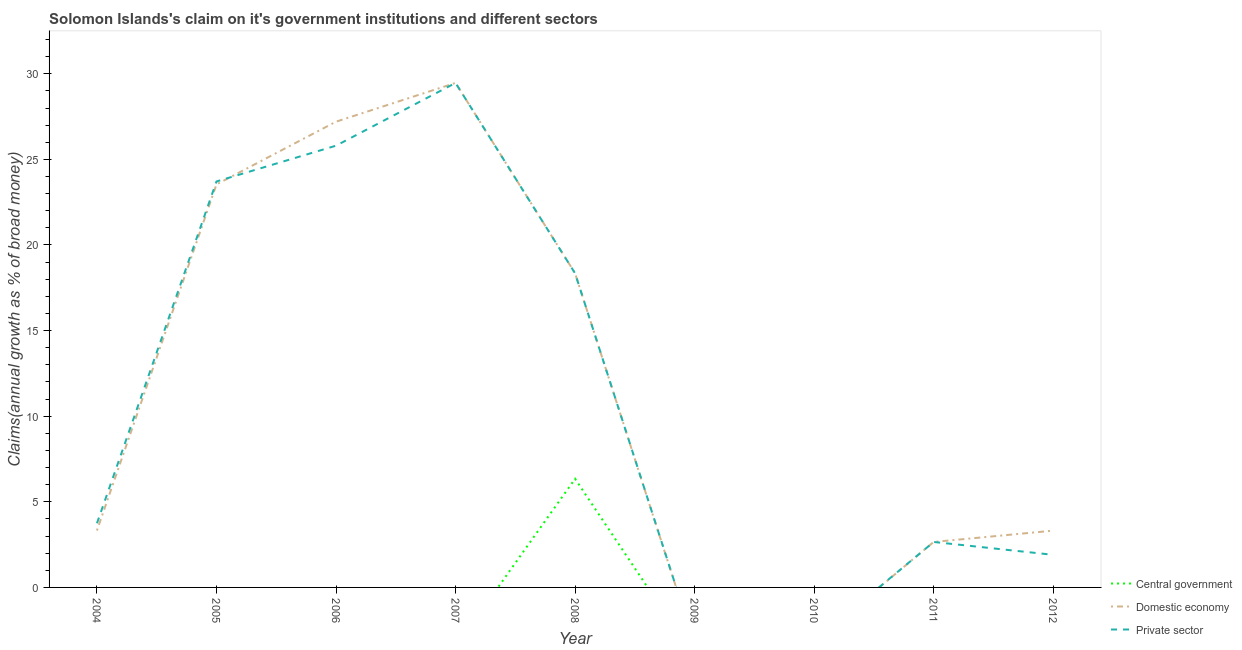Is the number of lines equal to the number of legend labels?
Offer a very short reply. No. What is the percentage of claim on the domestic economy in 2006?
Offer a terse response. 27.2. Across all years, what is the maximum percentage of claim on the domestic economy?
Ensure brevity in your answer.  29.47. In which year was the percentage of claim on the private sector maximum?
Ensure brevity in your answer.  2007. What is the total percentage of claim on the domestic economy in the graph?
Keep it short and to the point. 107.85. What is the difference between the percentage of claim on the private sector in 2006 and that in 2007?
Your answer should be very brief. -3.66. What is the average percentage of claim on the central government per year?
Offer a very short reply. 0.7. In the year 2007, what is the difference between the percentage of claim on the private sector and percentage of claim on the domestic economy?
Your answer should be very brief. -0. In how many years, is the percentage of claim on the private sector greater than 19 %?
Keep it short and to the point. 3. What is the ratio of the percentage of claim on the domestic economy in 2004 to that in 2012?
Provide a short and direct response. 1. Is the percentage of claim on the private sector in 2004 less than that in 2012?
Ensure brevity in your answer.  No. What is the difference between the highest and the second highest percentage of claim on the private sector?
Your answer should be very brief. 3.66. What is the difference between the highest and the lowest percentage of claim on the private sector?
Give a very brief answer. 29.47. In how many years, is the percentage of claim on the central government greater than the average percentage of claim on the central government taken over all years?
Give a very brief answer. 1. Is the sum of the percentage of claim on the private sector in 2007 and 2011 greater than the maximum percentage of claim on the domestic economy across all years?
Keep it short and to the point. Yes. Is it the case that in every year, the sum of the percentage of claim on the central government and percentage of claim on the domestic economy is greater than the percentage of claim on the private sector?
Offer a terse response. No. Does the graph contain any zero values?
Offer a very short reply. Yes. Does the graph contain grids?
Keep it short and to the point. No. How many legend labels are there?
Give a very brief answer. 3. How are the legend labels stacked?
Ensure brevity in your answer.  Vertical. What is the title of the graph?
Your answer should be very brief. Solomon Islands's claim on it's government institutions and different sectors. Does "Czech Republic" appear as one of the legend labels in the graph?
Keep it short and to the point. No. What is the label or title of the X-axis?
Ensure brevity in your answer.  Year. What is the label or title of the Y-axis?
Your answer should be compact. Claims(annual growth as % of broad money). What is the Claims(annual growth as % of broad money) in Central government in 2004?
Offer a terse response. 0. What is the Claims(annual growth as % of broad money) of Domestic economy in 2004?
Give a very brief answer. 3.32. What is the Claims(annual growth as % of broad money) of Private sector in 2004?
Your response must be concise. 3.75. What is the Claims(annual growth as % of broad money) of Central government in 2005?
Provide a succinct answer. 0. What is the Claims(annual growth as % of broad money) of Domestic economy in 2005?
Provide a succinct answer. 23.54. What is the Claims(annual growth as % of broad money) of Private sector in 2005?
Provide a short and direct response. 23.71. What is the Claims(annual growth as % of broad money) of Domestic economy in 2006?
Offer a terse response. 27.2. What is the Claims(annual growth as % of broad money) of Private sector in 2006?
Give a very brief answer. 25.8. What is the Claims(annual growth as % of broad money) in Domestic economy in 2007?
Ensure brevity in your answer.  29.47. What is the Claims(annual growth as % of broad money) in Private sector in 2007?
Provide a succinct answer. 29.47. What is the Claims(annual growth as % of broad money) of Central government in 2008?
Make the answer very short. 6.34. What is the Claims(annual growth as % of broad money) of Domestic economy in 2008?
Keep it short and to the point. 18.35. What is the Claims(annual growth as % of broad money) of Private sector in 2008?
Your answer should be very brief. 18.35. What is the Claims(annual growth as % of broad money) of Private sector in 2009?
Keep it short and to the point. 0. What is the Claims(annual growth as % of broad money) in Central government in 2011?
Keep it short and to the point. 0. What is the Claims(annual growth as % of broad money) in Domestic economy in 2011?
Give a very brief answer. 2.66. What is the Claims(annual growth as % of broad money) in Private sector in 2011?
Offer a very short reply. 2.66. What is the Claims(annual growth as % of broad money) of Central government in 2012?
Provide a short and direct response. 0. What is the Claims(annual growth as % of broad money) of Domestic economy in 2012?
Your answer should be very brief. 3.32. What is the Claims(annual growth as % of broad money) of Private sector in 2012?
Offer a very short reply. 1.9. Across all years, what is the maximum Claims(annual growth as % of broad money) of Central government?
Your answer should be compact. 6.34. Across all years, what is the maximum Claims(annual growth as % of broad money) in Domestic economy?
Ensure brevity in your answer.  29.47. Across all years, what is the maximum Claims(annual growth as % of broad money) of Private sector?
Provide a short and direct response. 29.47. Across all years, what is the minimum Claims(annual growth as % of broad money) of Domestic economy?
Give a very brief answer. 0. What is the total Claims(annual growth as % of broad money) of Central government in the graph?
Offer a very short reply. 6.34. What is the total Claims(annual growth as % of broad money) in Domestic economy in the graph?
Your answer should be compact. 107.85. What is the total Claims(annual growth as % of broad money) in Private sector in the graph?
Keep it short and to the point. 105.63. What is the difference between the Claims(annual growth as % of broad money) of Domestic economy in 2004 and that in 2005?
Provide a short and direct response. -20.21. What is the difference between the Claims(annual growth as % of broad money) in Private sector in 2004 and that in 2005?
Your response must be concise. -19.96. What is the difference between the Claims(annual growth as % of broad money) of Domestic economy in 2004 and that in 2006?
Give a very brief answer. -23.88. What is the difference between the Claims(annual growth as % of broad money) in Private sector in 2004 and that in 2006?
Make the answer very short. -22.05. What is the difference between the Claims(annual growth as % of broad money) in Domestic economy in 2004 and that in 2007?
Make the answer very short. -26.14. What is the difference between the Claims(annual growth as % of broad money) of Private sector in 2004 and that in 2007?
Your response must be concise. -25.72. What is the difference between the Claims(annual growth as % of broad money) of Domestic economy in 2004 and that in 2008?
Your answer should be very brief. -15.02. What is the difference between the Claims(annual growth as % of broad money) of Private sector in 2004 and that in 2008?
Provide a short and direct response. -14.6. What is the difference between the Claims(annual growth as % of broad money) of Domestic economy in 2004 and that in 2011?
Offer a very short reply. 0.67. What is the difference between the Claims(annual growth as % of broad money) of Private sector in 2004 and that in 2011?
Provide a short and direct response. 1.09. What is the difference between the Claims(annual growth as % of broad money) of Domestic economy in 2004 and that in 2012?
Make the answer very short. 0.01. What is the difference between the Claims(annual growth as % of broad money) in Private sector in 2004 and that in 2012?
Give a very brief answer. 1.84. What is the difference between the Claims(annual growth as % of broad money) in Domestic economy in 2005 and that in 2006?
Your answer should be very brief. -3.66. What is the difference between the Claims(annual growth as % of broad money) of Private sector in 2005 and that in 2006?
Your response must be concise. -2.09. What is the difference between the Claims(annual growth as % of broad money) of Domestic economy in 2005 and that in 2007?
Your answer should be compact. -5.93. What is the difference between the Claims(annual growth as % of broad money) of Private sector in 2005 and that in 2007?
Provide a short and direct response. -5.76. What is the difference between the Claims(annual growth as % of broad money) of Domestic economy in 2005 and that in 2008?
Provide a succinct answer. 5.19. What is the difference between the Claims(annual growth as % of broad money) in Private sector in 2005 and that in 2008?
Your response must be concise. 5.36. What is the difference between the Claims(annual growth as % of broad money) in Domestic economy in 2005 and that in 2011?
Offer a very short reply. 20.88. What is the difference between the Claims(annual growth as % of broad money) of Private sector in 2005 and that in 2011?
Give a very brief answer. 21.06. What is the difference between the Claims(annual growth as % of broad money) of Domestic economy in 2005 and that in 2012?
Offer a terse response. 20.22. What is the difference between the Claims(annual growth as % of broad money) in Private sector in 2005 and that in 2012?
Provide a short and direct response. 21.81. What is the difference between the Claims(annual growth as % of broad money) in Domestic economy in 2006 and that in 2007?
Make the answer very short. -2.26. What is the difference between the Claims(annual growth as % of broad money) of Private sector in 2006 and that in 2007?
Provide a short and direct response. -3.66. What is the difference between the Claims(annual growth as % of broad money) in Domestic economy in 2006 and that in 2008?
Give a very brief answer. 8.86. What is the difference between the Claims(annual growth as % of broad money) in Private sector in 2006 and that in 2008?
Provide a succinct answer. 7.45. What is the difference between the Claims(annual growth as % of broad money) of Domestic economy in 2006 and that in 2011?
Keep it short and to the point. 24.55. What is the difference between the Claims(annual growth as % of broad money) of Private sector in 2006 and that in 2011?
Your response must be concise. 23.15. What is the difference between the Claims(annual growth as % of broad money) of Domestic economy in 2006 and that in 2012?
Offer a very short reply. 23.89. What is the difference between the Claims(annual growth as % of broad money) of Private sector in 2006 and that in 2012?
Keep it short and to the point. 23.9. What is the difference between the Claims(annual growth as % of broad money) of Domestic economy in 2007 and that in 2008?
Make the answer very short. 11.12. What is the difference between the Claims(annual growth as % of broad money) in Private sector in 2007 and that in 2008?
Provide a short and direct response. 11.12. What is the difference between the Claims(annual growth as % of broad money) of Domestic economy in 2007 and that in 2011?
Provide a succinct answer. 26.81. What is the difference between the Claims(annual growth as % of broad money) in Private sector in 2007 and that in 2011?
Make the answer very short. 26.81. What is the difference between the Claims(annual growth as % of broad money) in Domestic economy in 2007 and that in 2012?
Your answer should be very brief. 26.15. What is the difference between the Claims(annual growth as % of broad money) in Private sector in 2007 and that in 2012?
Provide a succinct answer. 27.56. What is the difference between the Claims(annual growth as % of broad money) of Domestic economy in 2008 and that in 2011?
Make the answer very short. 15.69. What is the difference between the Claims(annual growth as % of broad money) in Private sector in 2008 and that in 2011?
Provide a succinct answer. 15.69. What is the difference between the Claims(annual growth as % of broad money) in Domestic economy in 2008 and that in 2012?
Give a very brief answer. 15.03. What is the difference between the Claims(annual growth as % of broad money) in Private sector in 2008 and that in 2012?
Give a very brief answer. 16.44. What is the difference between the Claims(annual growth as % of broad money) of Domestic economy in 2011 and that in 2012?
Your answer should be compact. -0.66. What is the difference between the Claims(annual growth as % of broad money) of Private sector in 2011 and that in 2012?
Your response must be concise. 0.75. What is the difference between the Claims(annual growth as % of broad money) in Domestic economy in 2004 and the Claims(annual growth as % of broad money) in Private sector in 2005?
Give a very brief answer. -20.39. What is the difference between the Claims(annual growth as % of broad money) of Domestic economy in 2004 and the Claims(annual growth as % of broad money) of Private sector in 2006?
Provide a short and direct response. -22.48. What is the difference between the Claims(annual growth as % of broad money) in Domestic economy in 2004 and the Claims(annual growth as % of broad money) in Private sector in 2007?
Make the answer very short. -26.14. What is the difference between the Claims(annual growth as % of broad money) of Domestic economy in 2004 and the Claims(annual growth as % of broad money) of Private sector in 2008?
Provide a succinct answer. -15.02. What is the difference between the Claims(annual growth as % of broad money) in Domestic economy in 2004 and the Claims(annual growth as % of broad money) in Private sector in 2011?
Your response must be concise. 0.67. What is the difference between the Claims(annual growth as % of broad money) in Domestic economy in 2004 and the Claims(annual growth as % of broad money) in Private sector in 2012?
Your answer should be very brief. 1.42. What is the difference between the Claims(annual growth as % of broad money) of Domestic economy in 2005 and the Claims(annual growth as % of broad money) of Private sector in 2006?
Your answer should be very brief. -2.26. What is the difference between the Claims(annual growth as % of broad money) of Domestic economy in 2005 and the Claims(annual growth as % of broad money) of Private sector in 2007?
Keep it short and to the point. -5.93. What is the difference between the Claims(annual growth as % of broad money) in Domestic economy in 2005 and the Claims(annual growth as % of broad money) in Private sector in 2008?
Give a very brief answer. 5.19. What is the difference between the Claims(annual growth as % of broad money) in Domestic economy in 2005 and the Claims(annual growth as % of broad money) in Private sector in 2011?
Offer a very short reply. 20.88. What is the difference between the Claims(annual growth as % of broad money) of Domestic economy in 2005 and the Claims(annual growth as % of broad money) of Private sector in 2012?
Make the answer very short. 21.64. What is the difference between the Claims(annual growth as % of broad money) in Domestic economy in 2006 and the Claims(annual growth as % of broad money) in Private sector in 2007?
Provide a short and direct response. -2.26. What is the difference between the Claims(annual growth as % of broad money) in Domestic economy in 2006 and the Claims(annual growth as % of broad money) in Private sector in 2008?
Your response must be concise. 8.86. What is the difference between the Claims(annual growth as % of broad money) in Domestic economy in 2006 and the Claims(annual growth as % of broad money) in Private sector in 2011?
Ensure brevity in your answer.  24.55. What is the difference between the Claims(annual growth as % of broad money) in Domestic economy in 2006 and the Claims(annual growth as % of broad money) in Private sector in 2012?
Your response must be concise. 25.3. What is the difference between the Claims(annual growth as % of broad money) of Domestic economy in 2007 and the Claims(annual growth as % of broad money) of Private sector in 2008?
Ensure brevity in your answer.  11.12. What is the difference between the Claims(annual growth as % of broad money) in Domestic economy in 2007 and the Claims(annual growth as % of broad money) in Private sector in 2011?
Keep it short and to the point. 26.81. What is the difference between the Claims(annual growth as % of broad money) in Domestic economy in 2007 and the Claims(annual growth as % of broad money) in Private sector in 2012?
Your response must be concise. 27.56. What is the difference between the Claims(annual growth as % of broad money) in Central government in 2008 and the Claims(annual growth as % of broad money) in Domestic economy in 2011?
Your response must be concise. 3.69. What is the difference between the Claims(annual growth as % of broad money) in Central government in 2008 and the Claims(annual growth as % of broad money) in Private sector in 2011?
Your answer should be very brief. 3.69. What is the difference between the Claims(annual growth as % of broad money) of Domestic economy in 2008 and the Claims(annual growth as % of broad money) of Private sector in 2011?
Ensure brevity in your answer.  15.69. What is the difference between the Claims(annual growth as % of broad money) in Central government in 2008 and the Claims(annual growth as % of broad money) in Domestic economy in 2012?
Your answer should be compact. 3.03. What is the difference between the Claims(annual growth as % of broad money) in Central government in 2008 and the Claims(annual growth as % of broad money) in Private sector in 2012?
Provide a short and direct response. 4.44. What is the difference between the Claims(annual growth as % of broad money) in Domestic economy in 2008 and the Claims(annual growth as % of broad money) in Private sector in 2012?
Offer a very short reply. 16.44. What is the difference between the Claims(annual growth as % of broad money) of Domestic economy in 2011 and the Claims(annual growth as % of broad money) of Private sector in 2012?
Your answer should be compact. 0.75. What is the average Claims(annual growth as % of broad money) in Central government per year?
Keep it short and to the point. 0.7. What is the average Claims(annual growth as % of broad money) of Domestic economy per year?
Keep it short and to the point. 11.98. What is the average Claims(annual growth as % of broad money) in Private sector per year?
Ensure brevity in your answer.  11.74. In the year 2004, what is the difference between the Claims(annual growth as % of broad money) of Domestic economy and Claims(annual growth as % of broad money) of Private sector?
Your answer should be compact. -0.42. In the year 2005, what is the difference between the Claims(annual growth as % of broad money) in Domestic economy and Claims(annual growth as % of broad money) in Private sector?
Provide a succinct answer. -0.17. In the year 2006, what is the difference between the Claims(annual growth as % of broad money) of Domestic economy and Claims(annual growth as % of broad money) of Private sector?
Provide a short and direct response. 1.4. In the year 2007, what is the difference between the Claims(annual growth as % of broad money) in Domestic economy and Claims(annual growth as % of broad money) in Private sector?
Your response must be concise. 0. In the year 2008, what is the difference between the Claims(annual growth as % of broad money) of Central government and Claims(annual growth as % of broad money) of Domestic economy?
Provide a succinct answer. -12. In the year 2008, what is the difference between the Claims(annual growth as % of broad money) of Central government and Claims(annual growth as % of broad money) of Private sector?
Your response must be concise. -12. In the year 2008, what is the difference between the Claims(annual growth as % of broad money) of Domestic economy and Claims(annual growth as % of broad money) of Private sector?
Offer a very short reply. 0. In the year 2011, what is the difference between the Claims(annual growth as % of broad money) of Domestic economy and Claims(annual growth as % of broad money) of Private sector?
Your response must be concise. 0. In the year 2012, what is the difference between the Claims(annual growth as % of broad money) of Domestic economy and Claims(annual growth as % of broad money) of Private sector?
Offer a terse response. 1.41. What is the ratio of the Claims(annual growth as % of broad money) in Domestic economy in 2004 to that in 2005?
Offer a very short reply. 0.14. What is the ratio of the Claims(annual growth as % of broad money) of Private sector in 2004 to that in 2005?
Your answer should be compact. 0.16. What is the ratio of the Claims(annual growth as % of broad money) of Domestic economy in 2004 to that in 2006?
Provide a succinct answer. 0.12. What is the ratio of the Claims(annual growth as % of broad money) of Private sector in 2004 to that in 2006?
Keep it short and to the point. 0.15. What is the ratio of the Claims(annual growth as % of broad money) in Domestic economy in 2004 to that in 2007?
Your answer should be compact. 0.11. What is the ratio of the Claims(annual growth as % of broad money) in Private sector in 2004 to that in 2007?
Your answer should be very brief. 0.13. What is the ratio of the Claims(annual growth as % of broad money) in Domestic economy in 2004 to that in 2008?
Your answer should be very brief. 0.18. What is the ratio of the Claims(annual growth as % of broad money) of Private sector in 2004 to that in 2008?
Give a very brief answer. 0.2. What is the ratio of the Claims(annual growth as % of broad money) of Domestic economy in 2004 to that in 2011?
Give a very brief answer. 1.25. What is the ratio of the Claims(annual growth as % of broad money) in Private sector in 2004 to that in 2011?
Give a very brief answer. 1.41. What is the ratio of the Claims(annual growth as % of broad money) of Domestic economy in 2004 to that in 2012?
Offer a very short reply. 1. What is the ratio of the Claims(annual growth as % of broad money) of Private sector in 2004 to that in 2012?
Provide a short and direct response. 1.97. What is the ratio of the Claims(annual growth as % of broad money) of Domestic economy in 2005 to that in 2006?
Your answer should be very brief. 0.87. What is the ratio of the Claims(annual growth as % of broad money) in Private sector in 2005 to that in 2006?
Keep it short and to the point. 0.92. What is the ratio of the Claims(annual growth as % of broad money) in Domestic economy in 2005 to that in 2007?
Your answer should be compact. 0.8. What is the ratio of the Claims(annual growth as % of broad money) in Private sector in 2005 to that in 2007?
Offer a terse response. 0.8. What is the ratio of the Claims(annual growth as % of broad money) of Domestic economy in 2005 to that in 2008?
Your response must be concise. 1.28. What is the ratio of the Claims(annual growth as % of broad money) in Private sector in 2005 to that in 2008?
Your answer should be compact. 1.29. What is the ratio of the Claims(annual growth as % of broad money) in Domestic economy in 2005 to that in 2011?
Your response must be concise. 8.86. What is the ratio of the Claims(annual growth as % of broad money) in Private sector in 2005 to that in 2011?
Your answer should be very brief. 8.93. What is the ratio of the Claims(annual growth as % of broad money) of Domestic economy in 2005 to that in 2012?
Ensure brevity in your answer.  7.1. What is the ratio of the Claims(annual growth as % of broad money) in Private sector in 2005 to that in 2012?
Provide a succinct answer. 12.46. What is the ratio of the Claims(annual growth as % of broad money) in Domestic economy in 2006 to that in 2007?
Provide a succinct answer. 0.92. What is the ratio of the Claims(annual growth as % of broad money) in Private sector in 2006 to that in 2007?
Give a very brief answer. 0.88. What is the ratio of the Claims(annual growth as % of broad money) of Domestic economy in 2006 to that in 2008?
Your answer should be compact. 1.48. What is the ratio of the Claims(annual growth as % of broad money) of Private sector in 2006 to that in 2008?
Your answer should be compact. 1.41. What is the ratio of the Claims(annual growth as % of broad money) of Domestic economy in 2006 to that in 2011?
Offer a terse response. 10.24. What is the ratio of the Claims(annual growth as % of broad money) in Private sector in 2006 to that in 2011?
Offer a very short reply. 9.72. What is the ratio of the Claims(annual growth as % of broad money) of Domestic economy in 2006 to that in 2012?
Provide a short and direct response. 8.2. What is the ratio of the Claims(annual growth as % of broad money) in Private sector in 2006 to that in 2012?
Your answer should be compact. 13.55. What is the ratio of the Claims(annual growth as % of broad money) in Domestic economy in 2007 to that in 2008?
Ensure brevity in your answer.  1.61. What is the ratio of the Claims(annual growth as % of broad money) in Private sector in 2007 to that in 2008?
Offer a very short reply. 1.61. What is the ratio of the Claims(annual growth as % of broad money) in Domestic economy in 2007 to that in 2011?
Your answer should be very brief. 11.09. What is the ratio of the Claims(annual growth as % of broad money) in Private sector in 2007 to that in 2011?
Provide a succinct answer. 11.1. What is the ratio of the Claims(annual growth as % of broad money) in Domestic economy in 2007 to that in 2012?
Offer a very short reply. 8.89. What is the ratio of the Claims(annual growth as % of broad money) in Private sector in 2007 to that in 2012?
Your answer should be compact. 15.48. What is the ratio of the Claims(annual growth as % of broad money) in Domestic economy in 2008 to that in 2011?
Provide a short and direct response. 6.91. What is the ratio of the Claims(annual growth as % of broad money) in Private sector in 2008 to that in 2011?
Give a very brief answer. 6.91. What is the ratio of the Claims(annual growth as % of broad money) in Domestic economy in 2008 to that in 2012?
Provide a succinct answer. 5.53. What is the ratio of the Claims(annual growth as % of broad money) of Private sector in 2008 to that in 2012?
Provide a succinct answer. 9.64. What is the ratio of the Claims(annual growth as % of broad money) in Domestic economy in 2011 to that in 2012?
Offer a terse response. 0.8. What is the ratio of the Claims(annual growth as % of broad money) of Private sector in 2011 to that in 2012?
Ensure brevity in your answer.  1.4. What is the difference between the highest and the second highest Claims(annual growth as % of broad money) of Domestic economy?
Your answer should be compact. 2.26. What is the difference between the highest and the second highest Claims(annual growth as % of broad money) of Private sector?
Offer a very short reply. 3.66. What is the difference between the highest and the lowest Claims(annual growth as % of broad money) of Central government?
Give a very brief answer. 6.34. What is the difference between the highest and the lowest Claims(annual growth as % of broad money) in Domestic economy?
Your answer should be compact. 29.47. What is the difference between the highest and the lowest Claims(annual growth as % of broad money) of Private sector?
Your answer should be very brief. 29.47. 